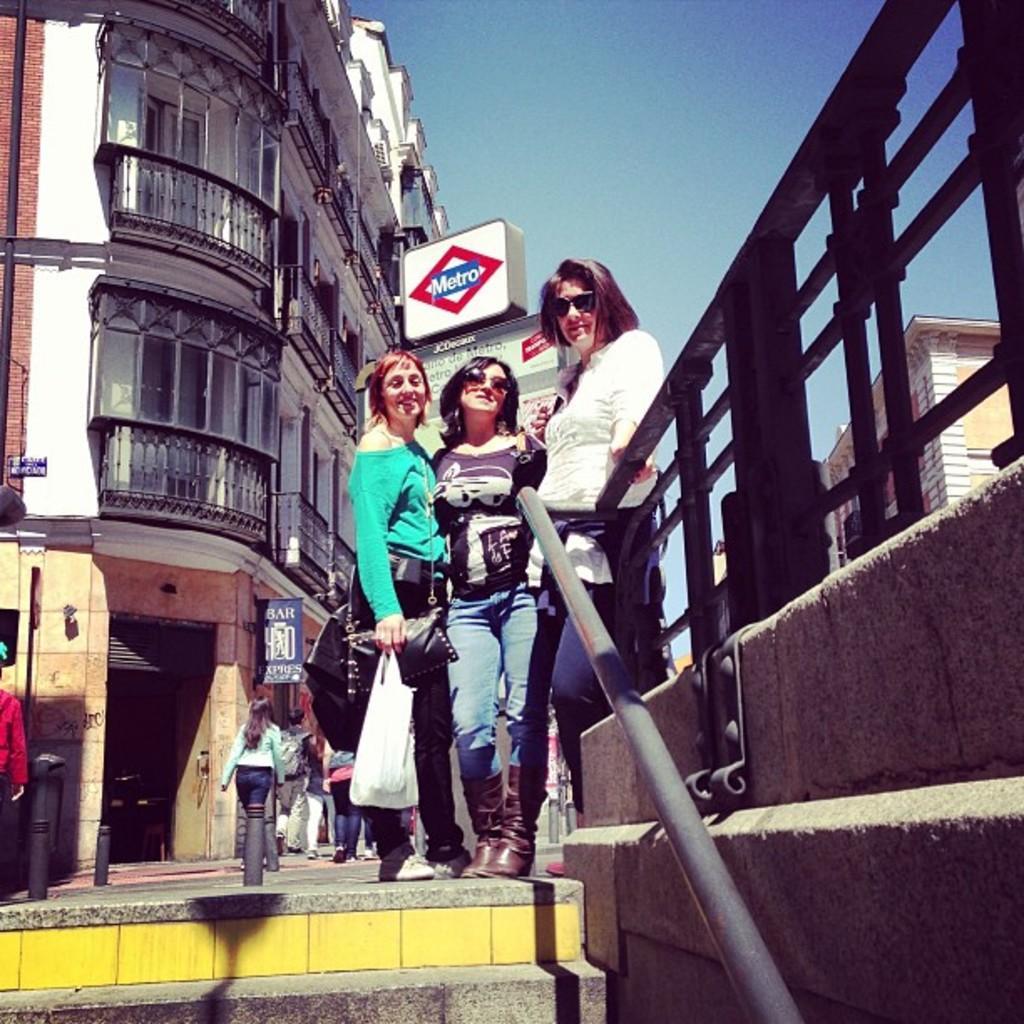In one or two sentences, can you explain what this image depicts? In this image we can see the buildings, few boards with text, few objects attached to the building, one fence, one object attached to the wall, some poles, one signal light, on staircase, one rod, one banner with text, few people are walking, three women standing, one person truncated on the left side of the image, two persons wearing bags, few people are holding objects and at the top there is the sky. 